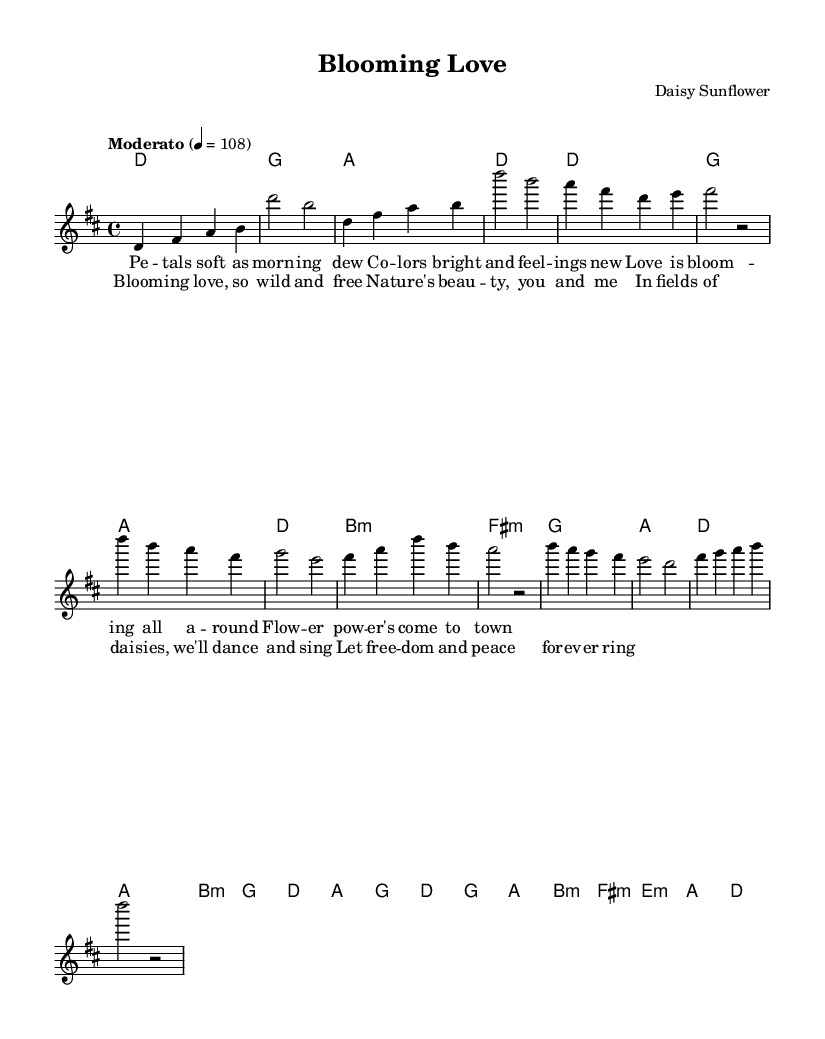What is the key signature of this music? The key signature is indicated in the global section, where it shows "d" with a major designation. This means the piece is in the D major key, which has two sharps (F# and C#).
Answer: D major What is the time signature of this music? The time signature is found in the global section and is indicated as "4/4," meaning there are four beats per measure and the quarter note receives one beat.
Answer: 4/4 What is the tempo marking for this piece? The tempo marking is specified in the global section where it states "Moderato" with a metronomic marking of 108 beats per minute, indicating a moderate tempo.
Answer: Moderato, 108 How many measures are in the verse section? By analyzing the verse part of the melody and the lyrics, it is found that there are four measures in the verse section. This is determined by counting the grouping of notes and the corresponding lyrics.
Answer: 4 What is the chord of the second measure of the chorus? The second measure of the chorus is identified in the harmonies section, and it shows an "a" chord, which corresponds to the note played in that measure.
Answer: a What is the lyrical theme presented in the chorus? The chorus lyrics mention concepts of blooming love and nature's beauty, highlighting a carefree and harmonious relationship with nature, which reflects the essence of flower power.
Answer: Blooming love, nature's beauty What type of music piece is this categorized as? This piece is categorized under the genre of pop music, particularly floral-inspired pop due to its lyrical content and harmonic structure reminiscent of 1960s flower power music.
Answer: Pop 